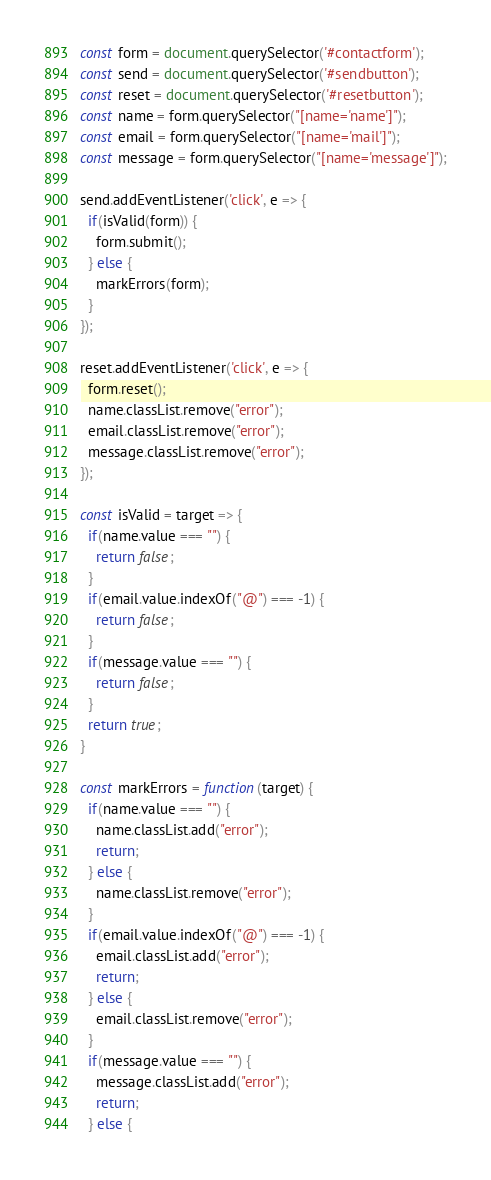Convert code to text. <code><loc_0><loc_0><loc_500><loc_500><_JavaScript_>const form = document.querySelector('#contactform');
const send = document.querySelector('#sendbutton');
const reset = document.querySelector('#resetbutton');
const name = form.querySelector("[name='name']");
const email = form.querySelector("[name='mail']");
const message = form.querySelector("[name='message']");

send.addEventListener('click', e => {
  if(isValid(form)) {
    form.submit();
  } else {
    markErrors(form);
  }
});

reset.addEventListener('click', e => {
  form.reset();
  name.classList.remove("error");
  email.classList.remove("error");
  message.classList.remove("error");
});

const isValid = target => {
  if(name.value === "") {
    return false;
  }
  if(email.value.indexOf("@") === -1) {
    return false;
  }
  if(message.value === "") {
    return false;
  }
  return true;
}

const markErrors = function(target) {
  if(name.value === "") {
    name.classList.add("error");
    return;
  } else {
    name.classList.remove("error");
  }
  if(email.value.indexOf("@") === -1) {
    email.classList.add("error");
    return;
  } else {
    email.classList.remove("error");
  }
  if(message.value === "") {
    message.classList.add("error");
    return;
  } else {</code> 